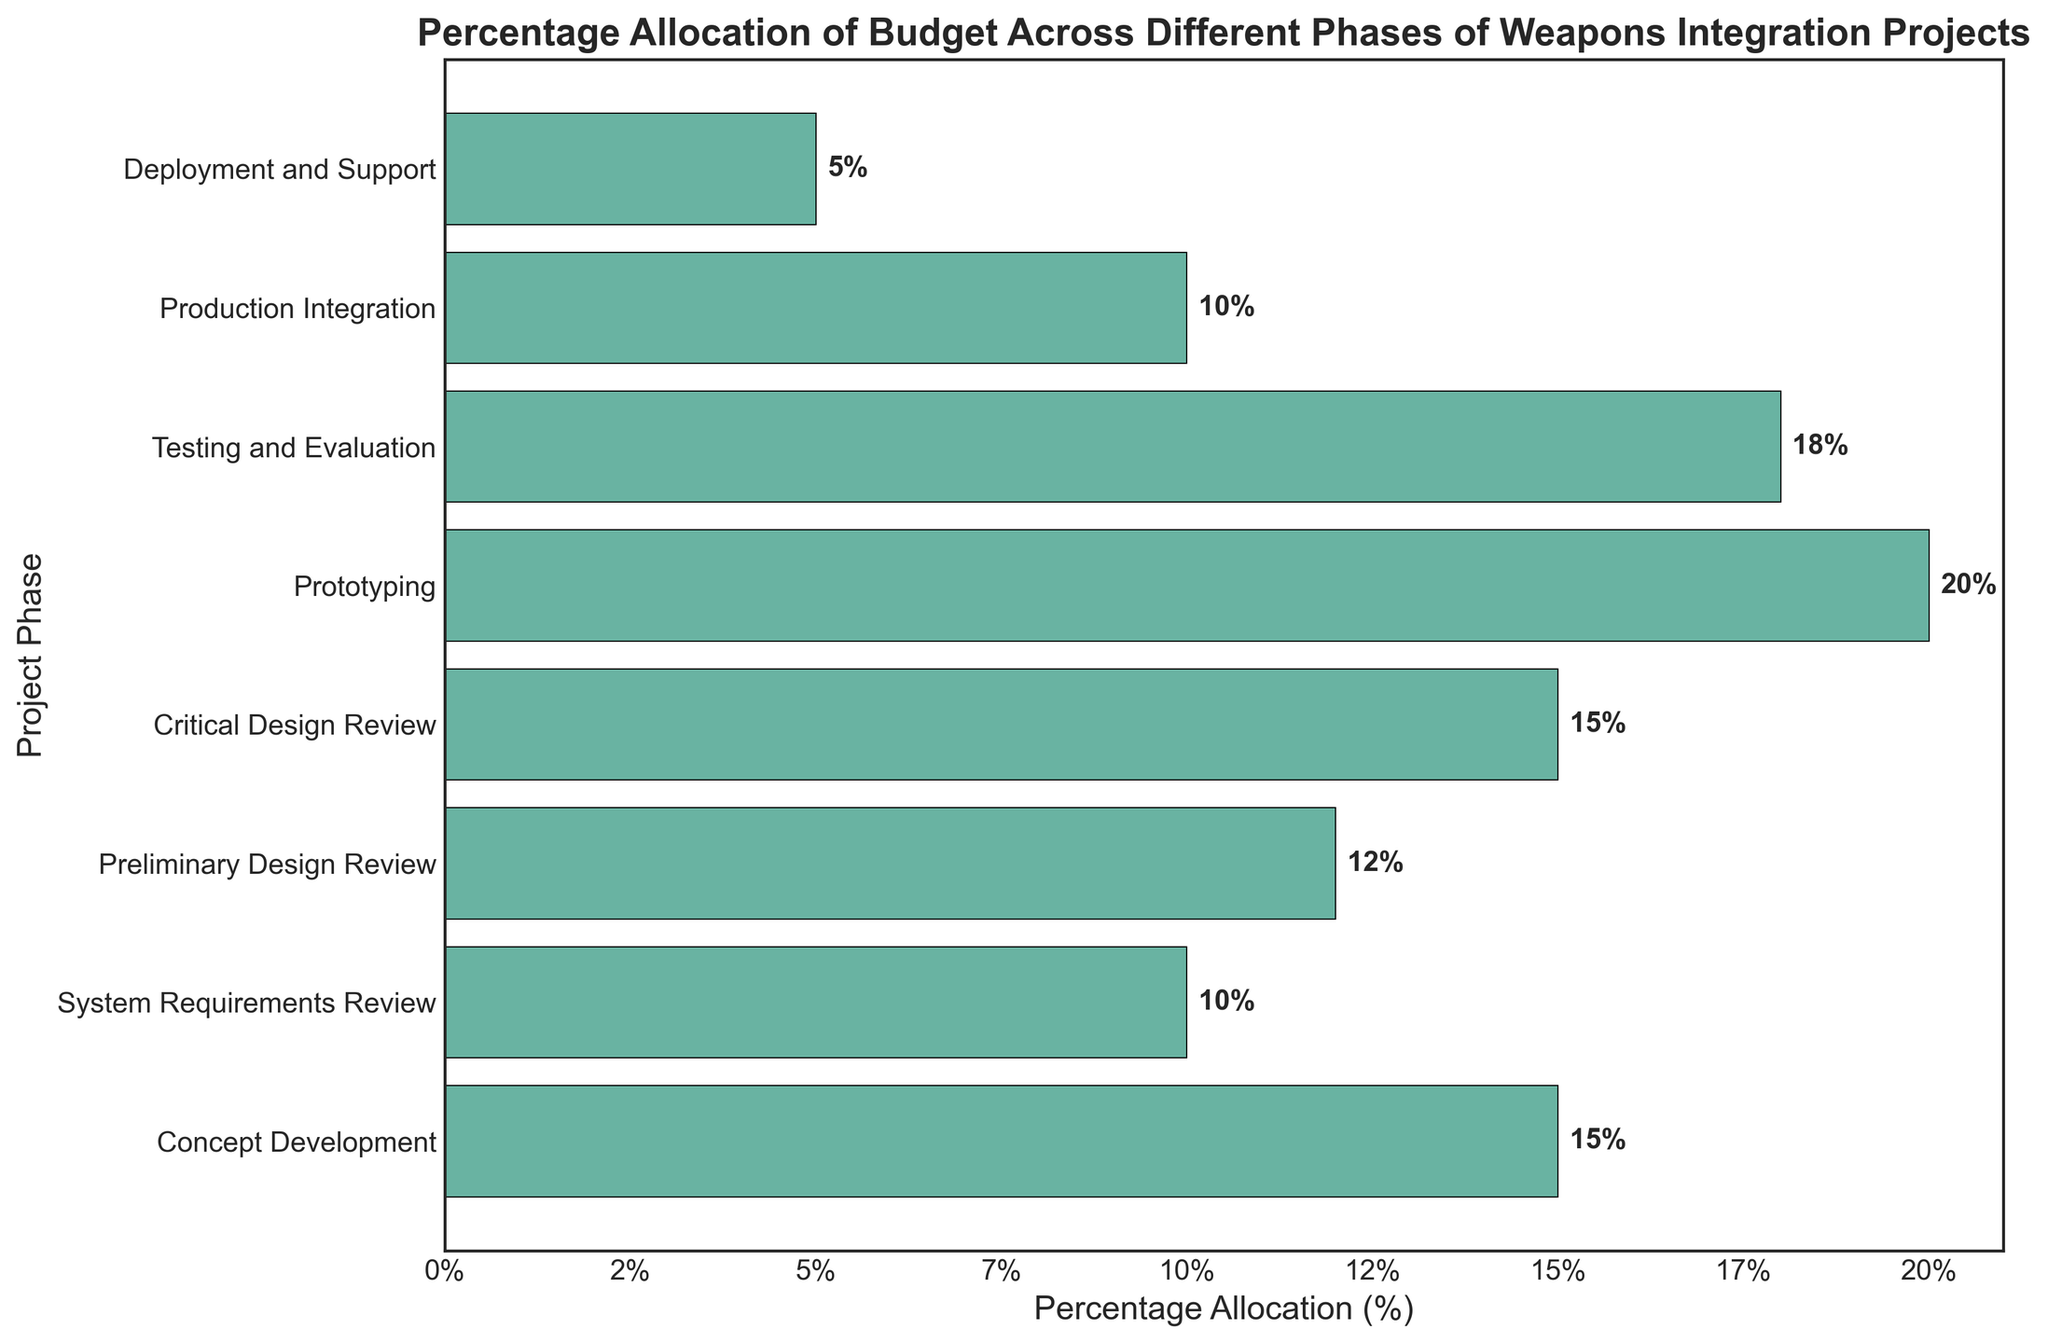What phase receives the highest percentage allocation? The phase with the longest bar represents the highest percentage allocation. The 'Prototyping' bar is the longest, indicating the highest percentage.
Answer: Prototyping What's the sum of the percentages allocated to 'Prototyping' and 'Testing and Evaluation'? Add the values next to the 'Prototyping' and 'Testing and Evaluation' bars: 20% (Prototyping) + 18% (Testing and Evaluation) = 38%.
Answer: 38% Which phase has the lowest budget allocation? The phase with the shortest bar represents the lowest budget allocation. The 'Deployment and Support' bar is the shortest, indicating the lowest percentage.
Answer: Deployment and Support How much more budget is allocated to 'Concept Development' compared to 'System Requirements Review'? Find the difference between the bars for 'Concept Development' and 'System Requirements Review': 15% (Concept Development) - 10% (System Requirements Review) = 5%.
Answer: 5% Are 'Preliminary Design Review' and 'Production Integration' allocated the same percentage of the budget? Compare the lengths of the bars for 'Preliminary Design Review' and 'Production Integration'. The 'Preliminary Design Review' bar is longer, indicating they are not the same.
Answer: No What's the total budget allocated to phases with more than 15% each? Identify the bars >15%: 'Prototyping' (20%) and 'Testing and Evaluation' (18%). Then sum: 20% + 18% = 38%.
Answer: 38% Which phase has a higher percentage allocation, 'Critical Design Review' or 'Production Integration'? Compare the bars for 'Critical Design Review' and 'Production Integration'. 'Critical Design Review' (15%) is longer than 'Production Integration' (10%).
Answer: Critical Design Review What is the average budget allocation across all phases? Sum all percentage allocations and divide by the number of phases: (15% + 10% + 12% + 15% + 20% + 18% + 10% + 5%) / 8 = 105% / 8 = 13.125%.
Answer: 13.125% Which phases have an equal percentage allocation of the budget? Compare the lengths of the bars, 'Concept Development' and 'Critical Design Review' both have 15%, and 'System Requirements Review' and 'Production Integration' both have 10%.
Answer: 'Concept Development' and 'Critical Design Review', 'System Requirements Review' and 'Production Integration' What percentage of the budget is allocated to phases before 'Prototyping'? Sum the percentages of the phases before 'Prototyping': 15% (Concept Development) + 10% (System Requirements Review) + 12% (Preliminary Design Review) + 15% (Critical Design Review) = 52%.
Answer: 52% 